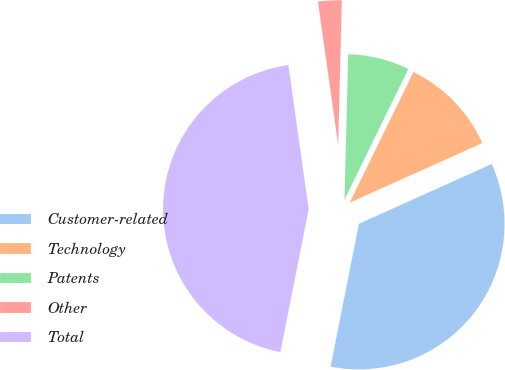<chart> <loc_0><loc_0><loc_500><loc_500><pie_chart><fcel>Customer-related<fcel>Technology<fcel>Patents<fcel>Other<fcel>Total<nl><fcel>34.84%<fcel>11.04%<fcel>6.83%<fcel>2.63%<fcel>44.66%<nl></chart> 